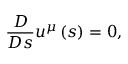Convert formula to latex. <formula><loc_0><loc_0><loc_500><loc_500>\frac { D } { D s } u ^ { \mu } \left ( s \right ) = 0 ,</formula> 